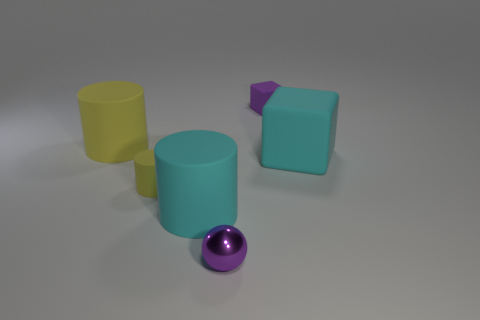Subtract all big rubber cylinders. How many cylinders are left? 1 Add 3 brown objects. How many objects exist? 9 Subtract 1 balls. How many balls are left? 0 Subtract all yellow balls. How many yellow cylinders are left? 2 Subtract all cubes. How many objects are left? 4 Subtract all purple blocks. How many blocks are left? 1 Subtract all brown cylinders. Subtract all purple balls. How many cylinders are left? 3 Subtract all large cyan blocks. Subtract all small yellow objects. How many objects are left? 4 Add 4 big yellow rubber objects. How many big yellow rubber objects are left? 5 Add 4 big blue rubber things. How many big blue rubber things exist? 4 